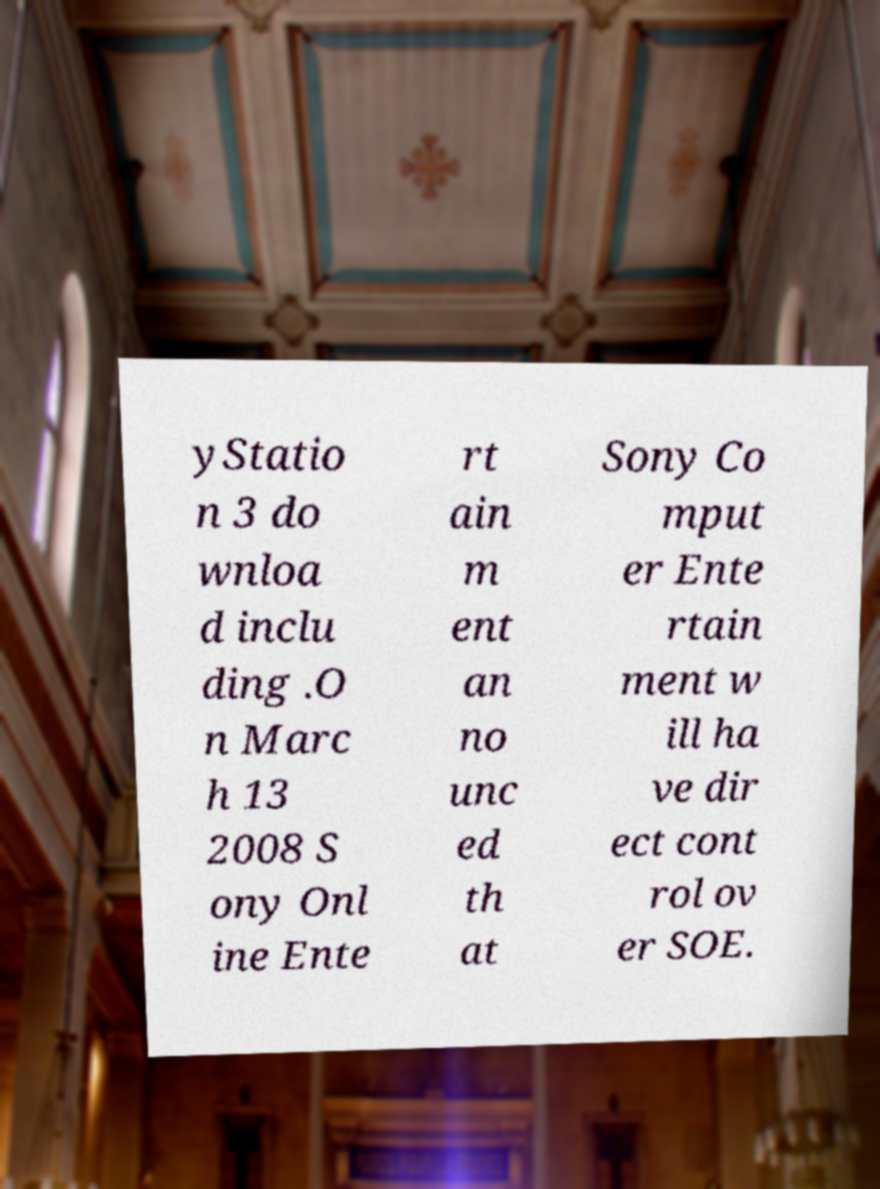For documentation purposes, I need the text within this image transcribed. Could you provide that? yStatio n 3 do wnloa d inclu ding .O n Marc h 13 2008 S ony Onl ine Ente rt ain m ent an no unc ed th at Sony Co mput er Ente rtain ment w ill ha ve dir ect cont rol ov er SOE. 